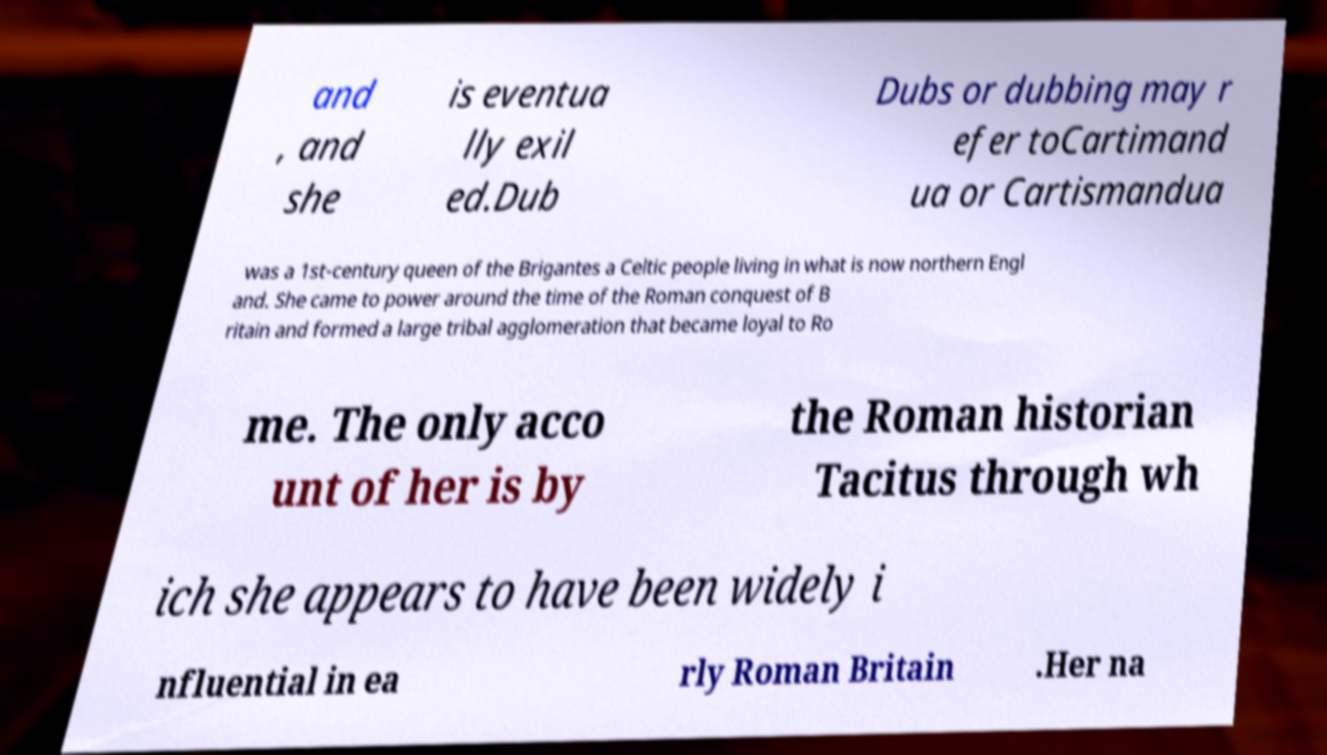Can you read and provide the text displayed in the image?This photo seems to have some interesting text. Can you extract and type it out for me? and , and she is eventua lly exil ed.Dub Dubs or dubbing may r efer toCartimand ua or Cartismandua was a 1st-century queen of the Brigantes a Celtic people living in what is now northern Engl and. She came to power around the time of the Roman conquest of B ritain and formed a large tribal agglomeration that became loyal to Ro me. The only acco unt of her is by the Roman historian Tacitus through wh ich she appears to have been widely i nfluential in ea rly Roman Britain .Her na 